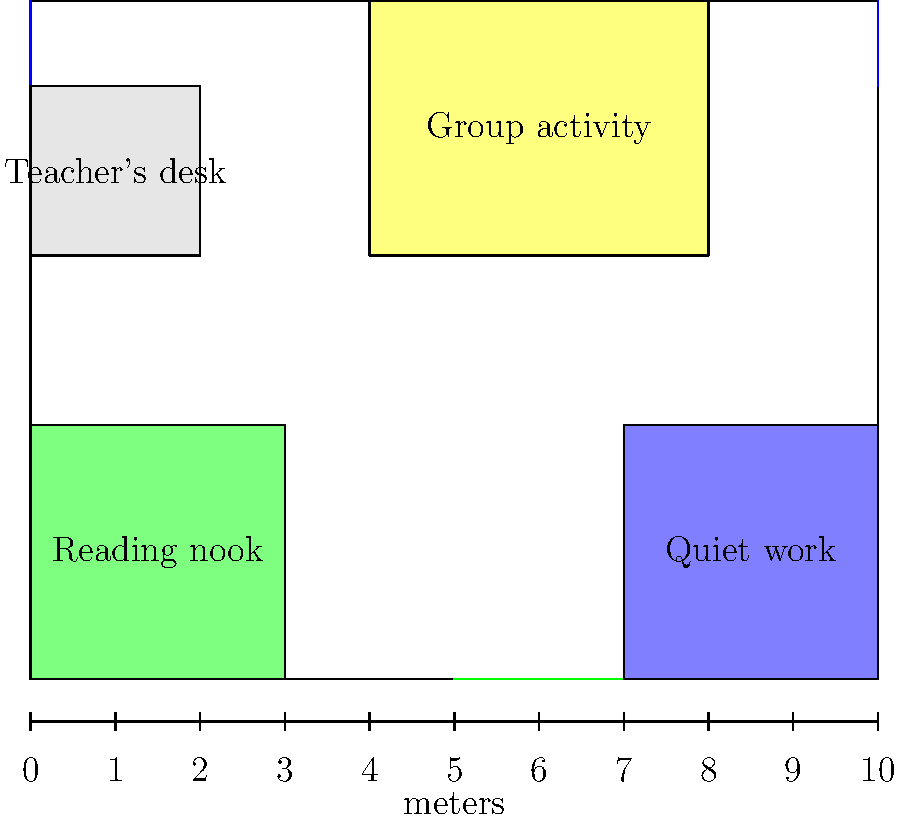Given the classroom floor plan above, which is designed to create a calming environment for children with anxiety, calculate the total area of the designated quiet spaces (reading nook and quiet work area) in square meters. To calculate the total area of the designated quiet spaces, we need to:

1. Identify the quiet spaces: reading nook and quiet work area.
2. Calculate the area of each space.
3. Sum the areas.

Step 1: Identify the quiet spaces
- Reading nook: bottom-left corner (green)
- Quiet work area: bottom-right corner (blue)

Step 2: Calculate the area of each space

Reading nook:
- Dimensions: 3m x 3m
- Area = length × width = 3m × 3m = 9 m²

Quiet work area:
- Dimensions: 3m x 3m
- Area = length × width = 3m × 3m = 9 m²

Step 3: Sum the areas
Total area = Area of reading nook + Area of quiet work area
Total area = 9 m² + 9 m² = 18 m²

Therefore, the total area of the designated quiet spaces is 18 square meters.
Answer: 18 m² 